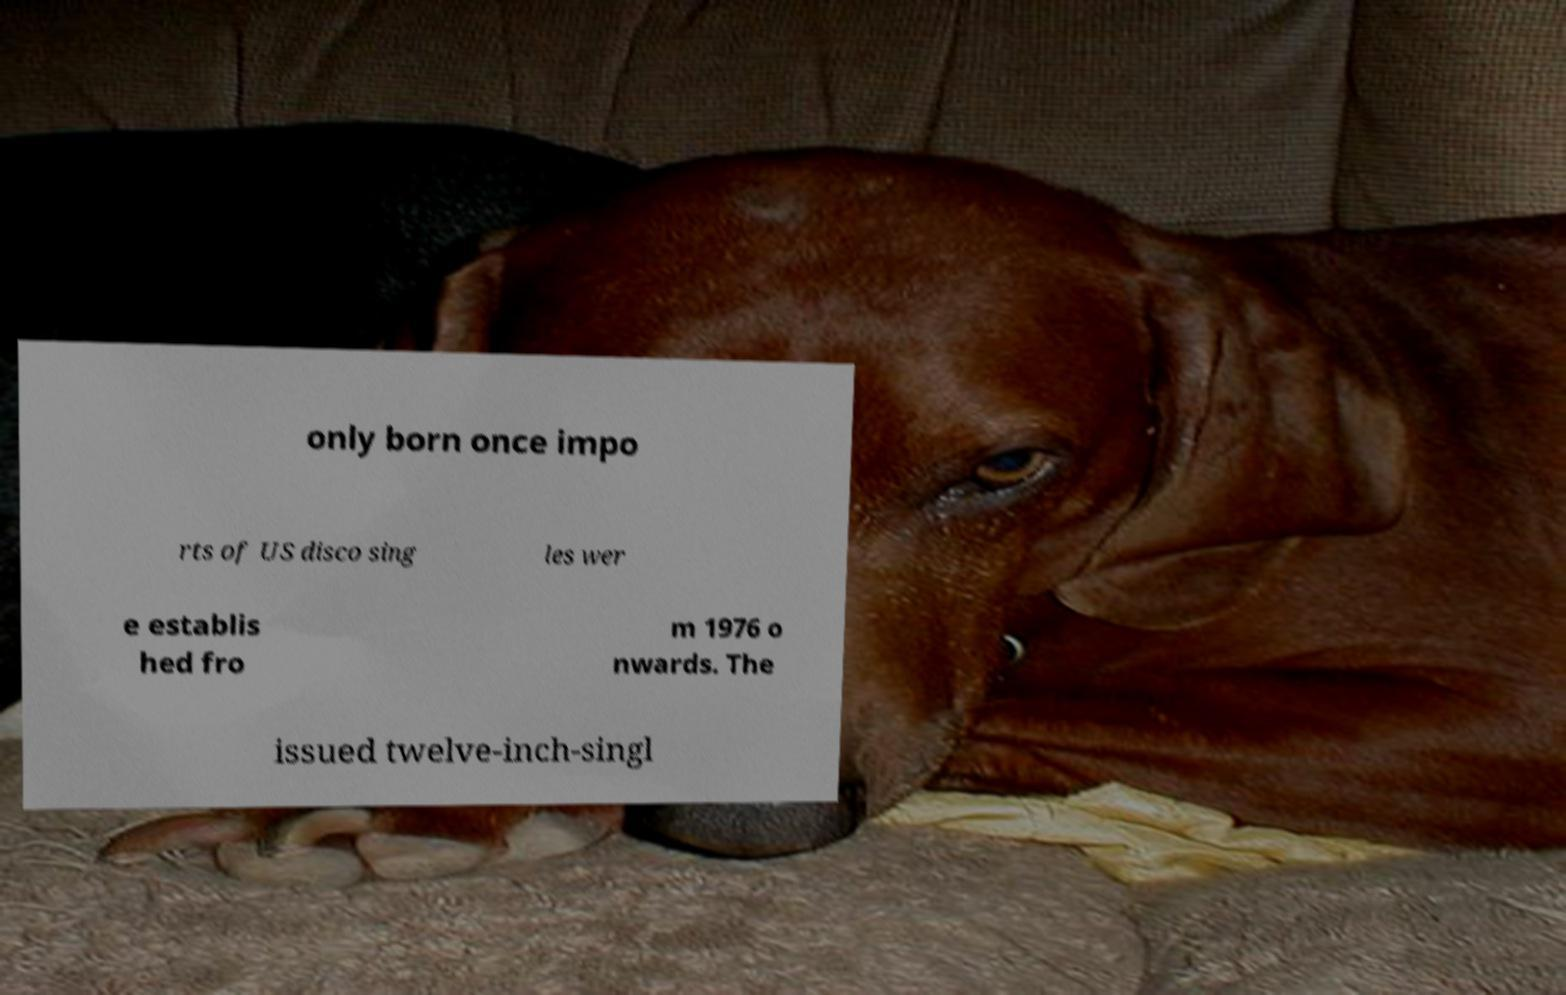Can you read and provide the text displayed in the image?This photo seems to have some interesting text. Can you extract and type it out for me? only born once impo rts of US disco sing les wer e establis hed fro m 1976 o nwards. The issued twelve-inch-singl 